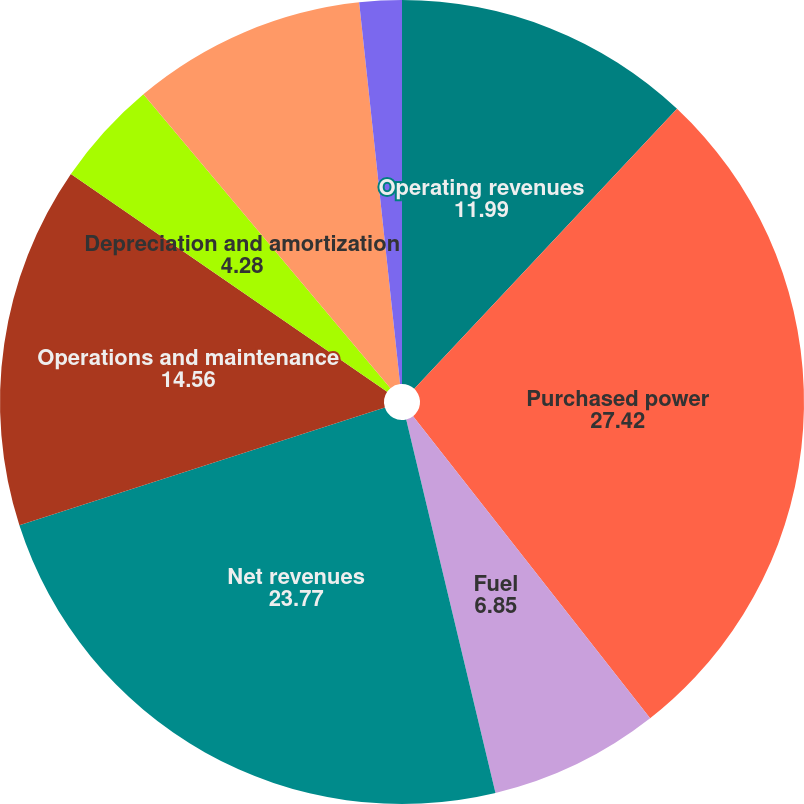Convert chart. <chart><loc_0><loc_0><loc_500><loc_500><pie_chart><fcel>Operating revenues<fcel>Purchased power<fcel>Fuel<fcel>Net revenues<fcel>Operations and maintenance<fcel>Depreciation and amortization<fcel>Taxes other than income taxes<fcel>Electric operating income<nl><fcel>11.99%<fcel>27.42%<fcel>6.85%<fcel>23.77%<fcel>14.56%<fcel>4.28%<fcel>9.42%<fcel>1.7%<nl></chart> 